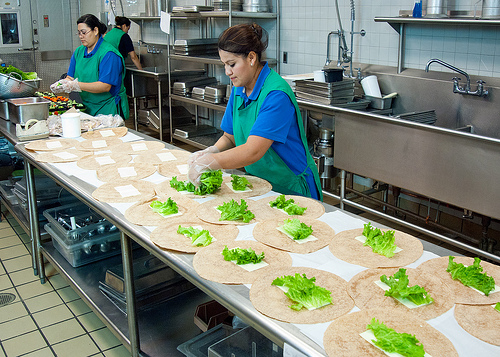What type of environment or establishment does this image depict? The image shows a professional kitchen environment, characterized by stainless steel appliances, large working areas, and multiple individuals involved in food preparation tasks. This setting indicates a commercial kitchen, possibly in a restaurant or a catering service. 